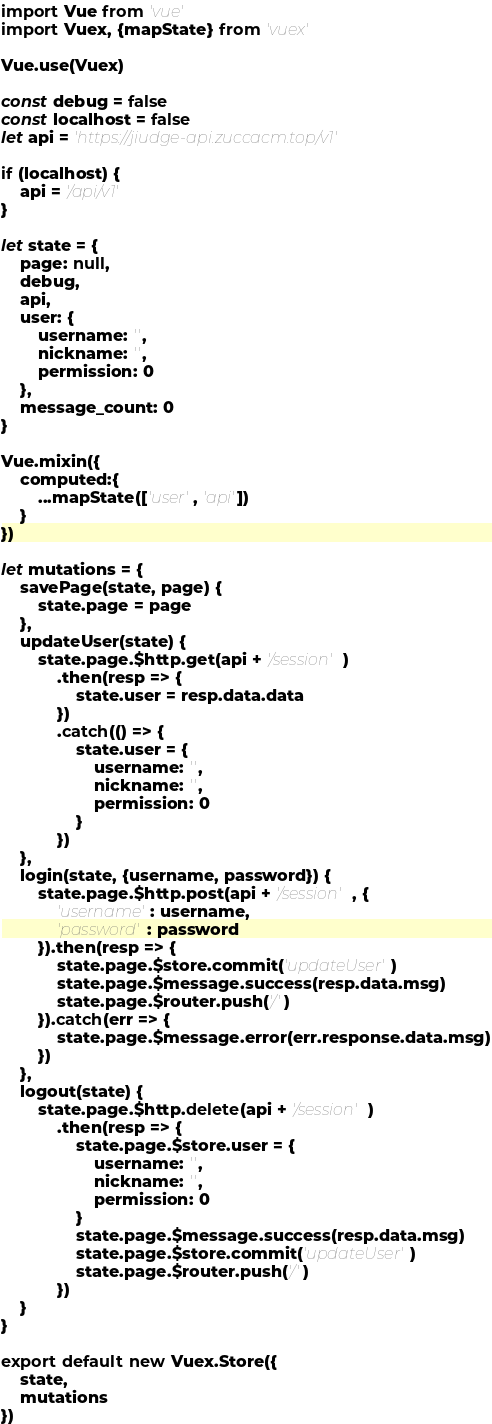Convert code to text. <code><loc_0><loc_0><loc_500><loc_500><_JavaScript_>import Vue from 'vue'
import Vuex, {mapState} from 'vuex'

Vue.use(Vuex)

const debug = false
const localhost = false
let api = 'https://jiudge-api.zuccacm.top/v1'

if (localhost) {
    api = '/api/v1'
}

let state = {
    page: null,
    debug,
    api,
    user: {
        username: '',
        nickname: '',
        permission: 0
    },
    message_count: 0
}

Vue.mixin({
    computed:{
        ...mapState(['user', 'api'])
    }
})

let mutations = {
    savePage(state, page) {
        state.page = page
    },
    updateUser(state) {
        state.page.$http.get(api + '/session')
            .then(resp => {
                state.user = resp.data.data
            })
            .catch(() => {
                state.user = {
                    username: '',
                    nickname: '',
                    permission: 0
                }
            })
    },
    login(state, {username, password}) {
        state.page.$http.post(api + '/session', {
            'username': username,
            'password': password
        }).then(resp => {
            state.page.$store.commit('updateUser')
            state.page.$message.success(resp.data.msg)
            state.page.$router.push('/')
        }).catch(err => {
            state.page.$message.error(err.response.data.msg)
        })
    },
    logout(state) {
        state.page.$http.delete(api + '/session')
            .then(resp => {
                state.page.$store.user = {
                    username: '',
                    nickname: '',
                    permission: 0
                }
                state.page.$message.success(resp.data.msg)
                state.page.$store.commit('updateUser')
                state.page.$router.push('/')
            })
    }
}

export default new Vuex.Store({
    state,
    mutations
})
</code> 